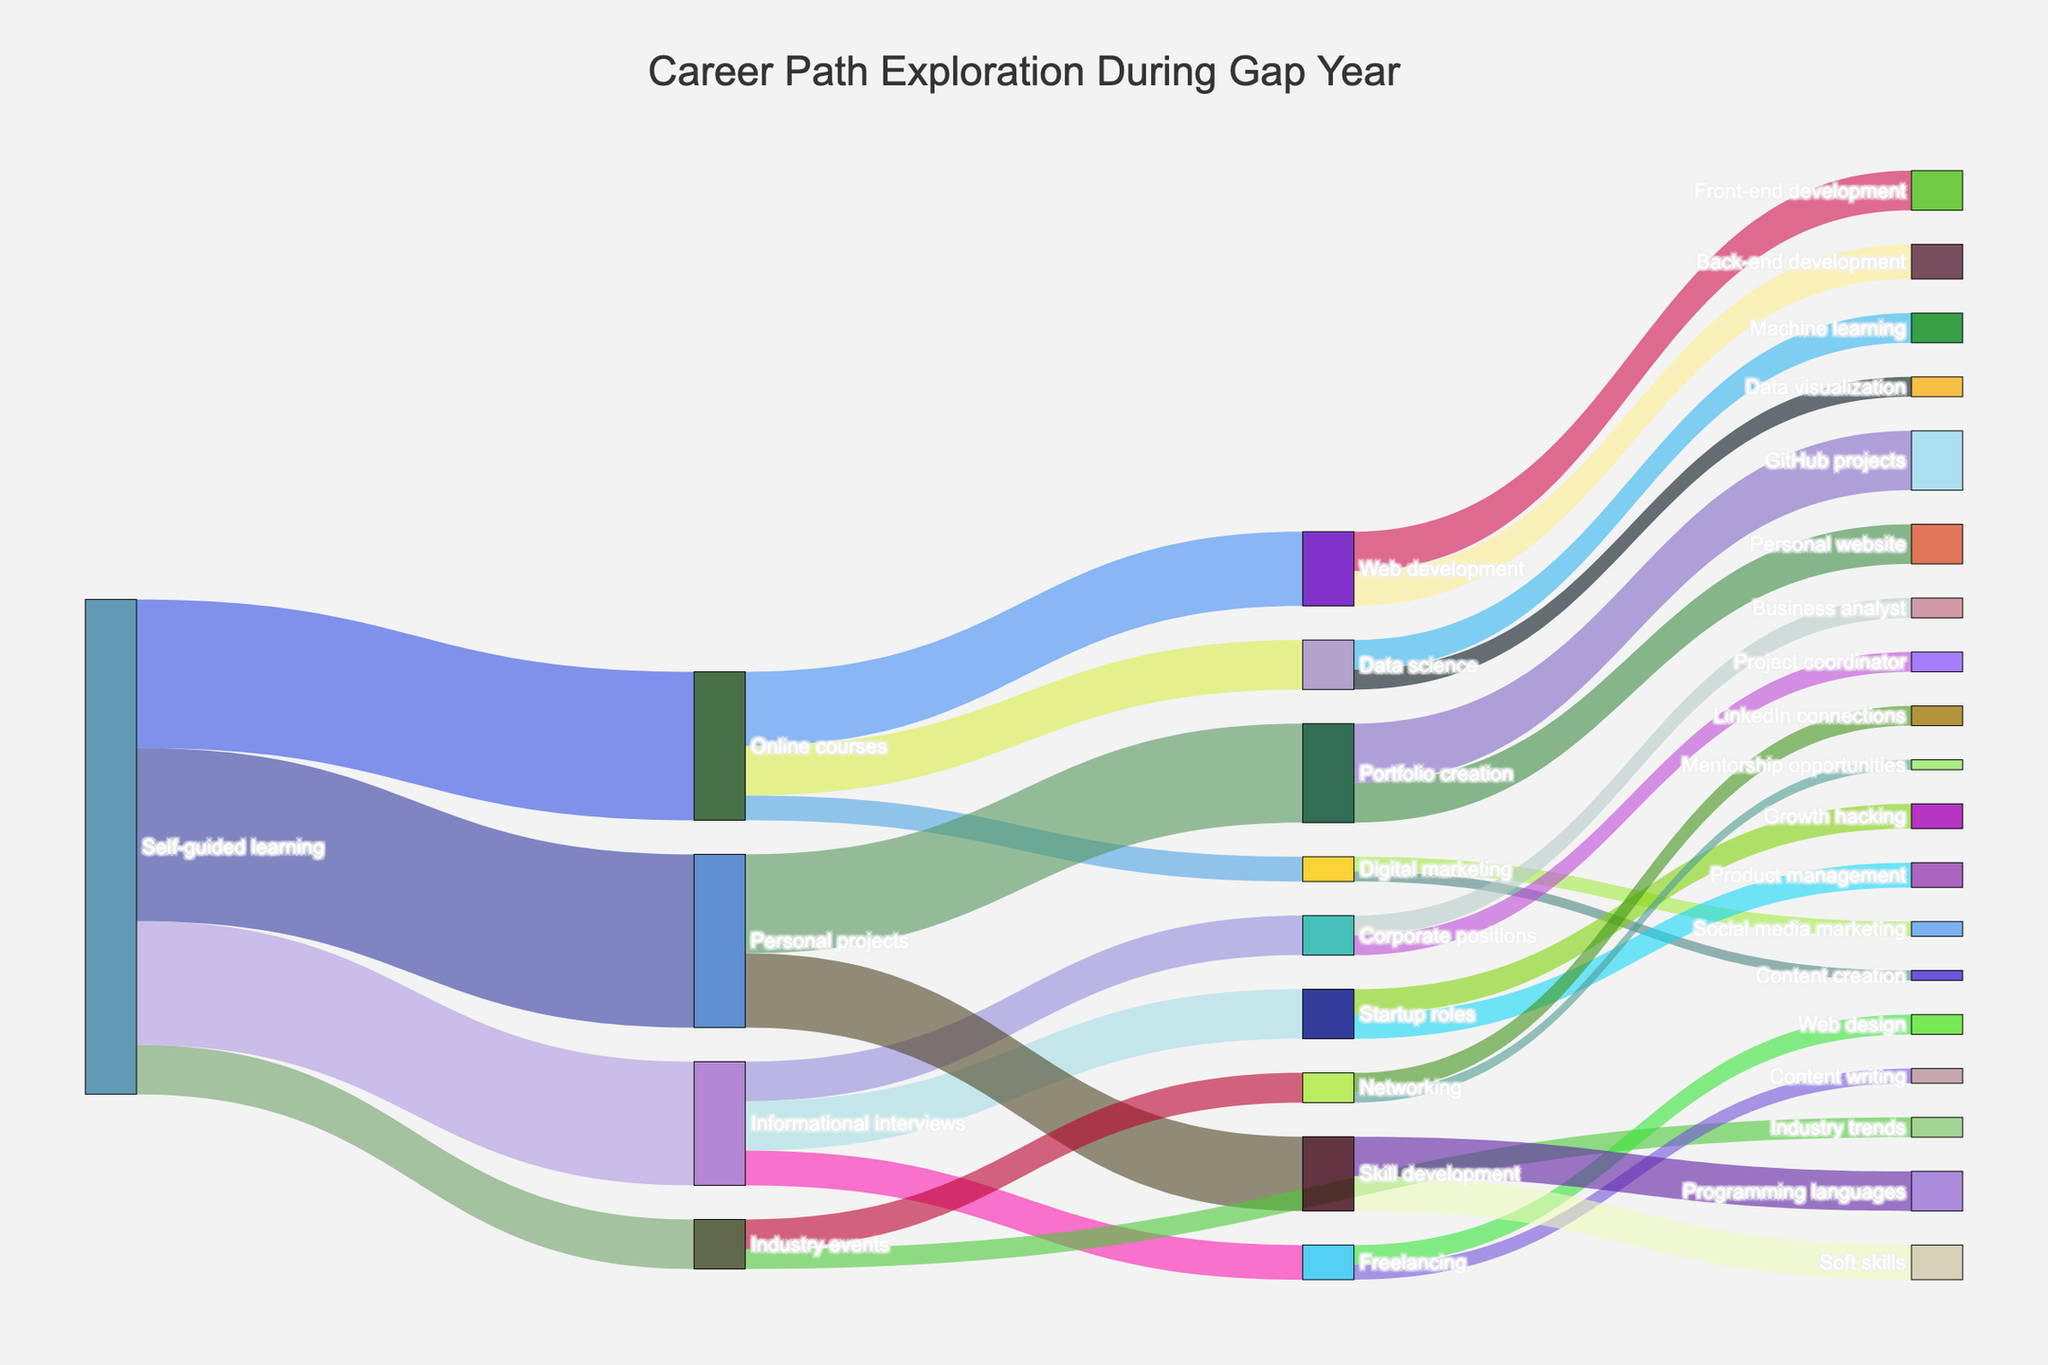What's the total value for all activities under "Self-guided learning"? To find the total value, sum up the values for all target activities directly connected to "Self-guided learning". These are Online courses (30), Informational interviews (25), Personal projects (35), and Industry events (10). The sum is 30 + 25 + 35 + 10 = 100.
Answer: 100 Which category under "Self-guided learning" has the highest value? Compare the values of Online courses (30), Informational interviews (25), Personal projects (35), and Industry events (10). The highest value is 35, which belongs to Personal projects.
Answer: Personal projects How many sub-categories fall under "Personal projects"? Identify the number of target nodes connected to "Personal projects". These are Portfolio creation and Skill development, making a total of 2 sub-categories.
Answer: 2 Which career path received the least attention from informational interviews? Compare the values for Startup roles (10), Corporate positions (8), and Freelancing (7) under "Informational interviews". Freelancing, with a value of 7, received the least attention.
Answer: Freelancing What is the total value for Web development paths? Sum up the values connected to Web development: Front-end development (8) and Back-end development (7). The total is 8 + 7 = 15.
Answer: 15 How many different categories are influenced by Industry events? Identify the number of target nodes connected to "Industry events". These are Networking and Industry trends, making a total of 2 categories.
Answer: 2 Which path under "Skill development" has a higher value? Compare the values of Programming languages (8) and Soft skills (7) under "Skill development". Programming languages has the higher value at 8.
Answer: Programming languages What’s the combined value for "Web development" and "Data science" under "Online courses"? Sum up the values for Web development (15) and Data science (10) under "Online courses". The combined value is 15 + 10 = 25.
Answer: 25 Which specialized area under online courses has the least engagement? Compare all the target values under "Online courses": Web development (15), Data science (10), and Digital marketing (5). Digital marketing, with a value of 5, has the least engagement.
Answer: Digital marketing 